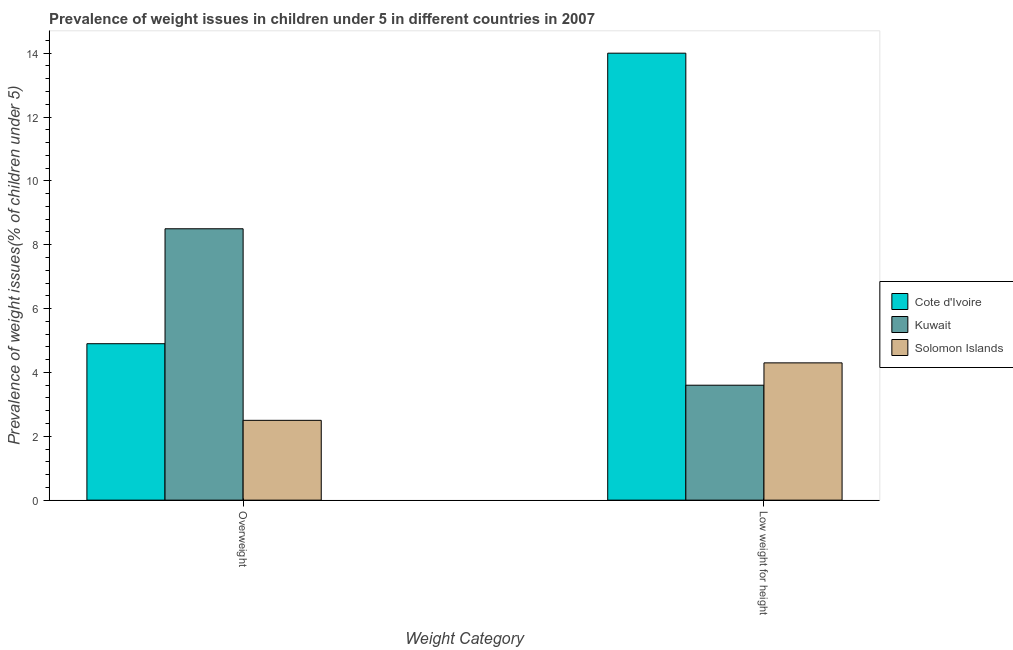How many different coloured bars are there?
Provide a succinct answer. 3. Are the number of bars on each tick of the X-axis equal?
Offer a terse response. Yes. How many bars are there on the 2nd tick from the left?
Keep it short and to the point. 3. How many bars are there on the 2nd tick from the right?
Provide a short and direct response. 3. What is the label of the 1st group of bars from the left?
Give a very brief answer. Overweight. What is the percentage of underweight children in Kuwait?
Ensure brevity in your answer.  3.6. Across all countries, what is the maximum percentage of overweight children?
Your response must be concise. 8.5. Across all countries, what is the minimum percentage of underweight children?
Keep it short and to the point. 3.6. In which country was the percentage of overweight children maximum?
Make the answer very short. Kuwait. In which country was the percentage of overweight children minimum?
Your response must be concise. Solomon Islands. What is the total percentage of overweight children in the graph?
Provide a succinct answer. 15.9. What is the difference between the percentage of overweight children in Kuwait and that in Cote d'Ivoire?
Provide a succinct answer. 3.6. What is the difference between the percentage of underweight children in Cote d'Ivoire and the percentage of overweight children in Kuwait?
Make the answer very short. 5.5. What is the average percentage of underweight children per country?
Provide a succinct answer. 7.3. What is the difference between the percentage of overweight children and percentage of underweight children in Solomon Islands?
Provide a succinct answer. -1.8. In how many countries, is the percentage of underweight children greater than 3.6 %?
Offer a very short reply. 2. Is the percentage of underweight children in Solomon Islands less than that in Cote d'Ivoire?
Make the answer very short. Yes. In how many countries, is the percentage of underweight children greater than the average percentage of underweight children taken over all countries?
Offer a terse response. 1. What does the 1st bar from the left in Overweight represents?
Your answer should be very brief. Cote d'Ivoire. What does the 2nd bar from the right in Low weight for height represents?
Offer a very short reply. Kuwait. Are all the bars in the graph horizontal?
Ensure brevity in your answer.  No. How many countries are there in the graph?
Make the answer very short. 3. What is the difference between two consecutive major ticks on the Y-axis?
Your answer should be compact. 2. What is the title of the graph?
Keep it short and to the point. Prevalence of weight issues in children under 5 in different countries in 2007. What is the label or title of the X-axis?
Make the answer very short. Weight Category. What is the label or title of the Y-axis?
Provide a succinct answer. Prevalence of weight issues(% of children under 5). What is the Prevalence of weight issues(% of children under 5) in Cote d'Ivoire in Overweight?
Ensure brevity in your answer.  4.9. What is the Prevalence of weight issues(% of children under 5) of Cote d'Ivoire in Low weight for height?
Offer a terse response. 14. What is the Prevalence of weight issues(% of children under 5) in Kuwait in Low weight for height?
Your answer should be compact. 3.6. What is the Prevalence of weight issues(% of children under 5) in Solomon Islands in Low weight for height?
Offer a terse response. 4.3. Across all Weight Category, what is the maximum Prevalence of weight issues(% of children under 5) of Solomon Islands?
Offer a terse response. 4.3. Across all Weight Category, what is the minimum Prevalence of weight issues(% of children under 5) of Cote d'Ivoire?
Provide a succinct answer. 4.9. Across all Weight Category, what is the minimum Prevalence of weight issues(% of children under 5) of Kuwait?
Provide a succinct answer. 3.6. What is the total Prevalence of weight issues(% of children under 5) in Kuwait in the graph?
Ensure brevity in your answer.  12.1. What is the difference between the Prevalence of weight issues(% of children under 5) of Cote d'Ivoire in Overweight and that in Low weight for height?
Your answer should be very brief. -9.1. What is the difference between the Prevalence of weight issues(% of children under 5) in Kuwait in Overweight and that in Low weight for height?
Provide a short and direct response. 4.9. What is the difference between the Prevalence of weight issues(% of children under 5) in Cote d'Ivoire in Overweight and the Prevalence of weight issues(% of children under 5) in Kuwait in Low weight for height?
Your answer should be very brief. 1.3. What is the difference between the Prevalence of weight issues(% of children under 5) in Cote d'Ivoire in Overweight and the Prevalence of weight issues(% of children under 5) in Solomon Islands in Low weight for height?
Keep it short and to the point. 0.6. What is the difference between the Prevalence of weight issues(% of children under 5) in Kuwait in Overweight and the Prevalence of weight issues(% of children under 5) in Solomon Islands in Low weight for height?
Your answer should be compact. 4.2. What is the average Prevalence of weight issues(% of children under 5) of Cote d'Ivoire per Weight Category?
Make the answer very short. 9.45. What is the average Prevalence of weight issues(% of children under 5) in Kuwait per Weight Category?
Your answer should be compact. 6.05. What is the difference between the Prevalence of weight issues(% of children under 5) in Cote d'Ivoire and Prevalence of weight issues(% of children under 5) in Kuwait in Overweight?
Ensure brevity in your answer.  -3.6. What is the difference between the Prevalence of weight issues(% of children under 5) in Cote d'Ivoire and Prevalence of weight issues(% of children under 5) in Solomon Islands in Overweight?
Keep it short and to the point. 2.4. What is the difference between the Prevalence of weight issues(% of children under 5) of Kuwait and Prevalence of weight issues(% of children under 5) of Solomon Islands in Low weight for height?
Provide a succinct answer. -0.7. What is the ratio of the Prevalence of weight issues(% of children under 5) of Kuwait in Overweight to that in Low weight for height?
Make the answer very short. 2.36. What is the ratio of the Prevalence of weight issues(% of children under 5) in Solomon Islands in Overweight to that in Low weight for height?
Ensure brevity in your answer.  0.58. What is the difference between the highest and the second highest Prevalence of weight issues(% of children under 5) in Kuwait?
Provide a short and direct response. 4.9. What is the difference between the highest and the lowest Prevalence of weight issues(% of children under 5) of Cote d'Ivoire?
Offer a terse response. 9.1. What is the difference between the highest and the lowest Prevalence of weight issues(% of children under 5) of Solomon Islands?
Your response must be concise. 1.8. 